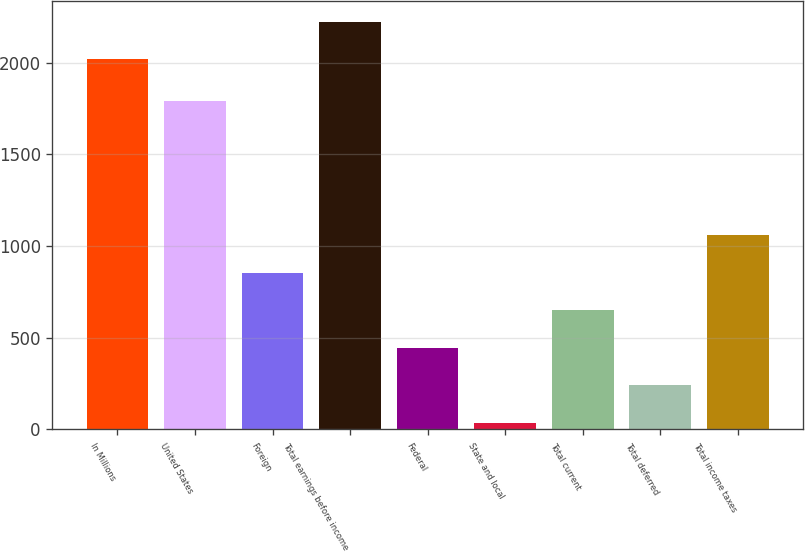<chart> <loc_0><loc_0><loc_500><loc_500><bar_chart><fcel>In Millions<fcel>United States<fcel>Foreign<fcel>Total earnings before income<fcel>Federal<fcel>State and local<fcel>Total current<fcel>Total deferred<fcel>Total income taxes<nl><fcel>2019<fcel>1788.2<fcel>853.98<fcel>2223.67<fcel>444.64<fcel>35.3<fcel>649.31<fcel>239.97<fcel>1058.65<nl></chart> 